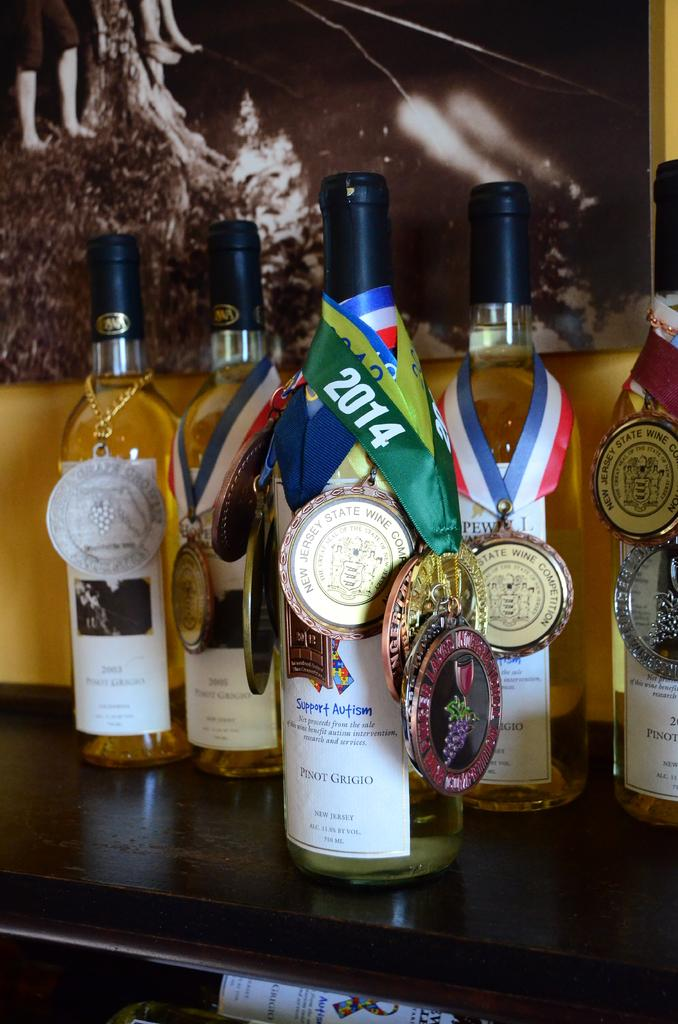What is hanging around the neck of the bottles in the image? There are medals around the neck of the bottles in the image. What type of surface is the bottles and medals resting on? This is a table in the image. What can be seen in the distance behind the bottles and table? There is a scenery visible in the background of the image. What is the profit margin of the knee in the image? There is no knee present in the image, and therefore no profit margin can be determined. 